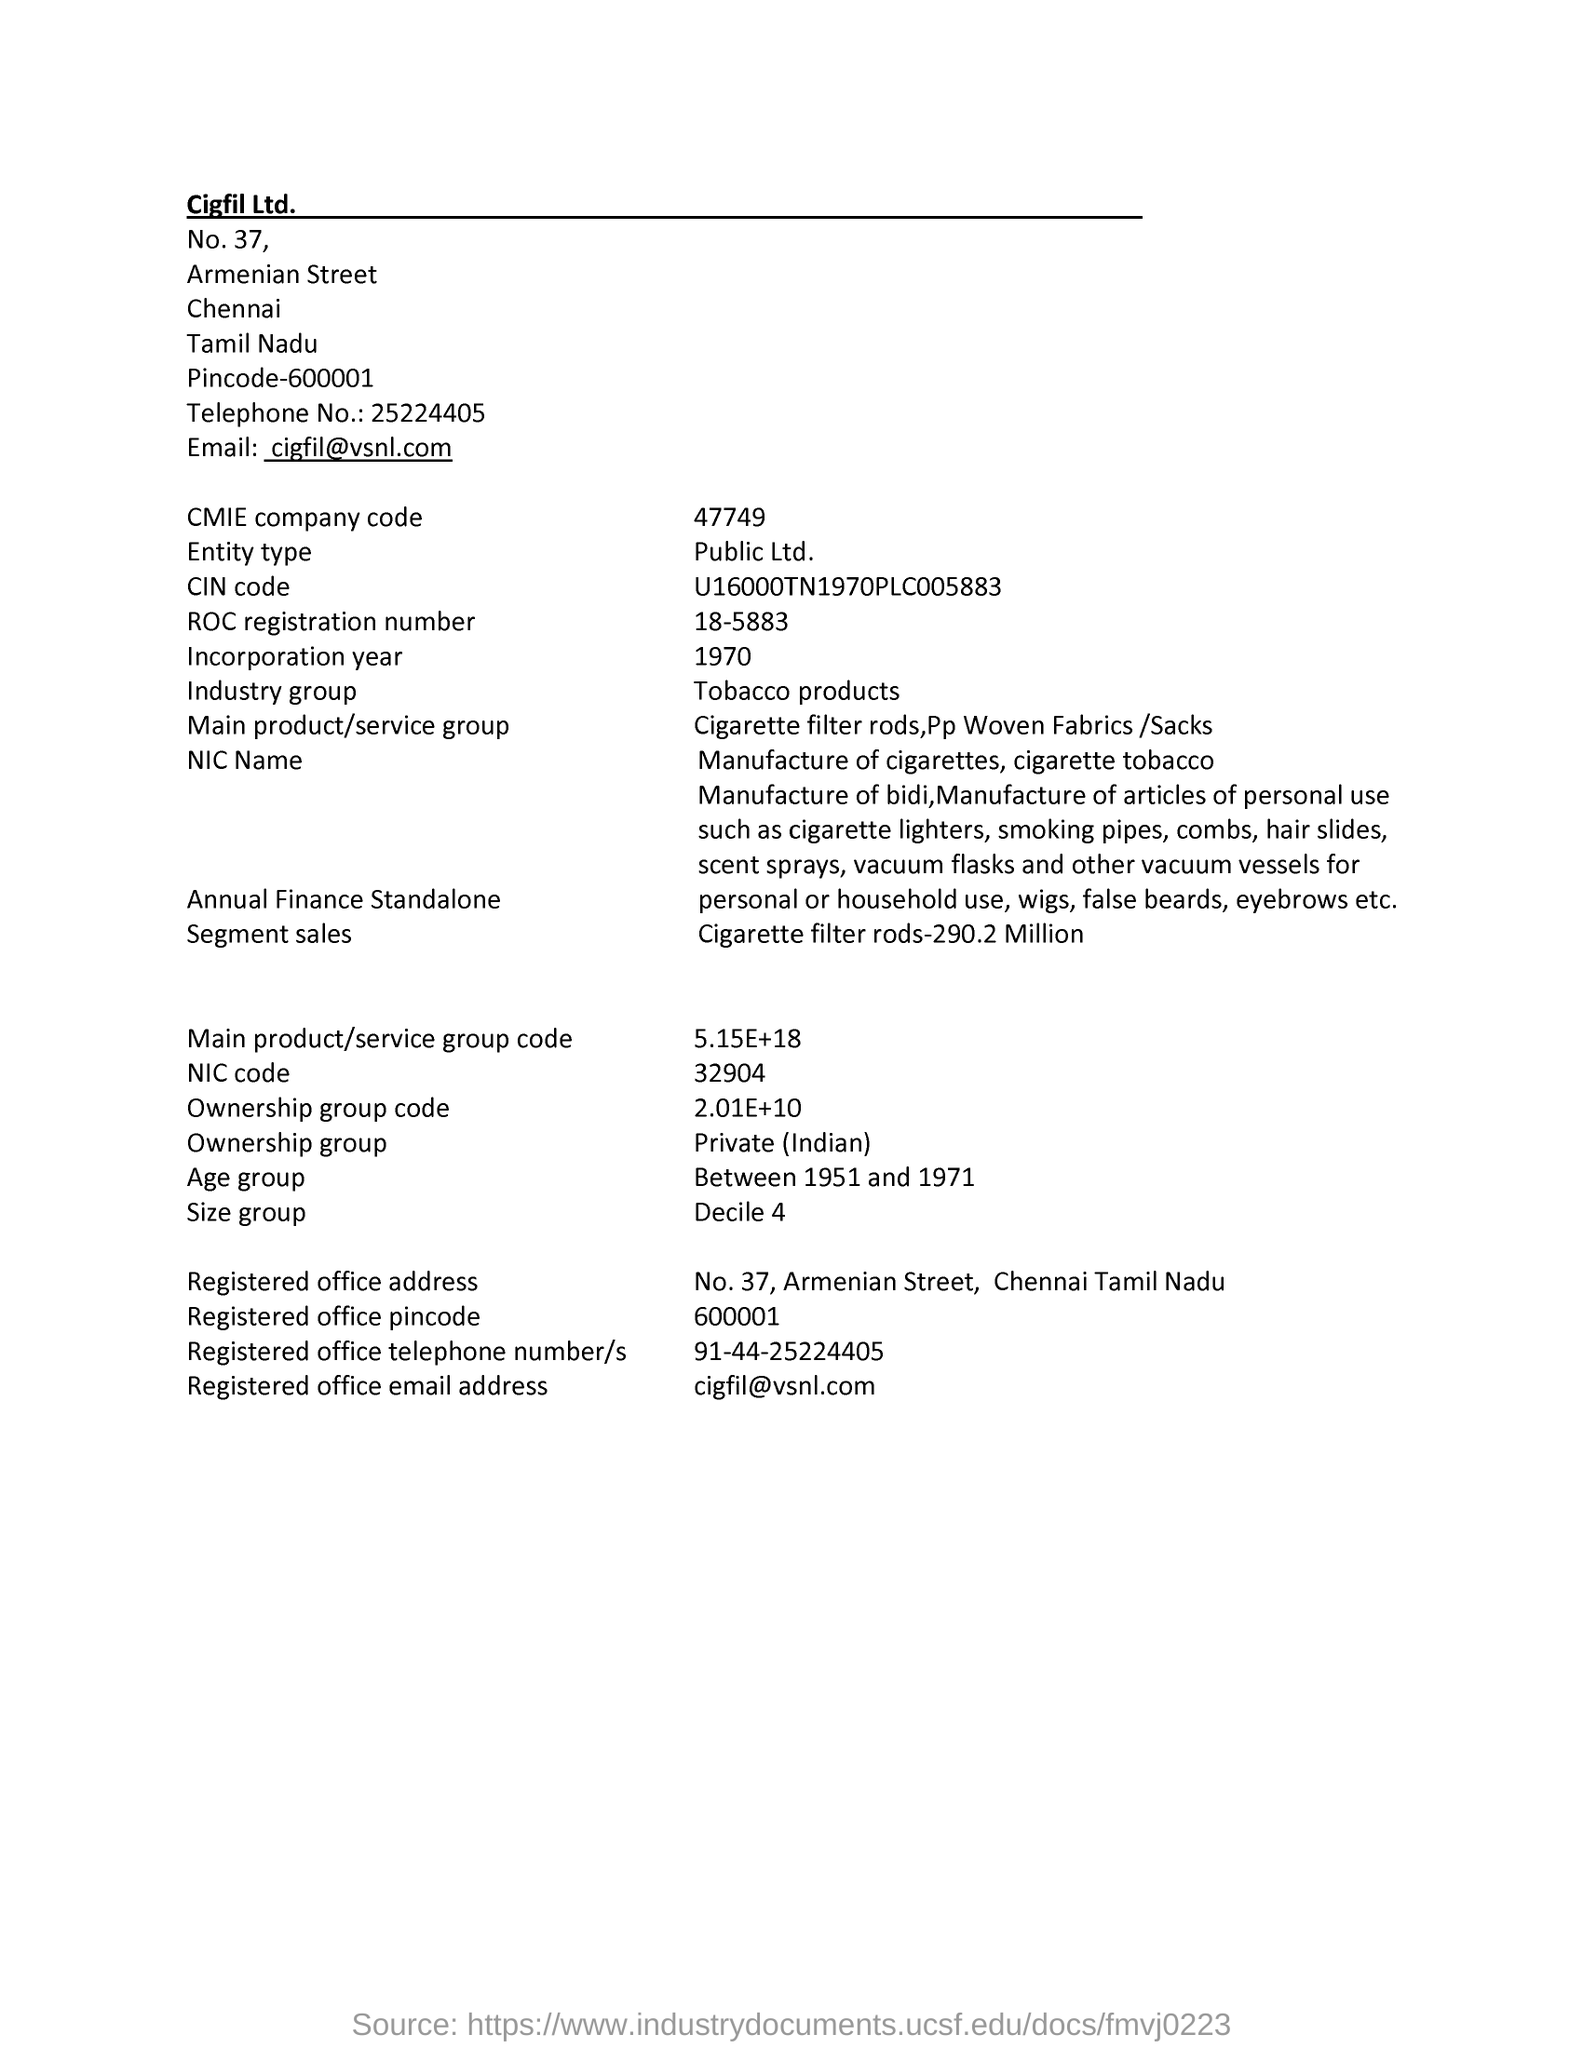Point out several critical features in this image. The registered telephone number/s mentioned on the page are 91-44-25224405.. What is the ROC registration number displayed on the page? 18-5883... The age group mentioned on the page is between 1951 and 1971. The industry group mentioned on the page is tobacco products. The CMIE company code mentioned in the page is 47749. 